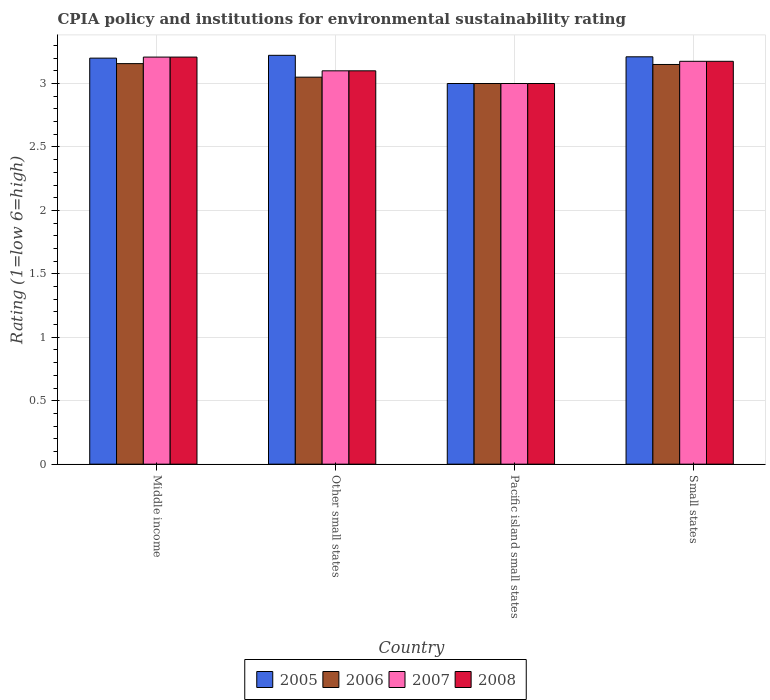How many different coloured bars are there?
Offer a very short reply. 4. How many groups of bars are there?
Your answer should be compact. 4. Are the number of bars per tick equal to the number of legend labels?
Your answer should be compact. Yes. Are the number of bars on each tick of the X-axis equal?
Your answer should be very brief. Yes. How many bars are there on the 4th tick from the left?
Provide a short and direct response. 4. What is the label of the 2nd group of bars from the left?
Provide a short and direct response. Other small states. What is the CPIA rating in 2005 in Other small states?
Ensure brevity in your answer.  3.22. Across all countries, what is the maximum CPIA rating in 2008?
Offer a very short reply. 3.21. Across all countries, what is the minimum CPIA rating in 2006?
Offer a terse response. 3. In which country was the CPIA rating in 2008 maximum?
Make the answer very short. Middle income. In which country was the CPIA rating in 2006 minimum?
Provide a short and direct response. Pacific island small states. What is the total CPIA rating in 2008 in the graph?
Make the answer very short. 12.48. What is the difference between the CPIA rating in 2006 in Middle income and that in Pacific island small states?
Offer a very short reply. 0.16. What is the difference between the CPIA rating in 2006 in Pacific island small states and the CPIA rating in 2005 in Other small states?
Your response must be concise. -0.22. What is the average CPIA rating in 2006 per country?
Offer a very short reply. 3.09. What is the difference between the CPIA rating of/in 2008 and CPIA rating of/in 2006 in Small states?
Keep it short and to the point. 0.02. What is the ratio of the CPIA rating in 2007 in Middle income to that in Other small states?
Ensure brevity in your answer.  1.03. Is the CPIA rating in 2007 in Pacific island small states less than that in Small states?
Ensure brevity in your answer.  Yes. Is the difference between the CPIA rating in 2008 in Middle income and Small states greater than the difference between the CPIA rating in 2006 in Middle income and Small states?
Offer a very short reply. Yes. What is the difference between the highest and the second highest CPIA rating in 2006?
Make the answer very short. -0.01. What is the difference between the highest and the lowest CPIA rating in 2008?
Your answer should be very brief. 0.21. In how many countries, is the CPIA rating in 2008 greater than the average CPIA rating in 2008 taken over all countries?
Give a very brief answer. 2. Is the sum of the CPIA rating in 2006 in Middle income and Pacific island small states greater than the maximum CPIA rating in 2008 across all countries?
Make the answer very short. Yes. Is it the case that in every country, the sum of the CPIA rating in 2006 and CPIA rating in 2008 is greater than the sum of CPIA rating in 2007 and CPIA rating in 2005?
Provide a succinct answer. No. What does the 4th bar from the left in Middle income represents?
Your answer should be compact. 2008. Are all the bars in the graph horizontal?
Keep it short and to the point. No. Does the graph contain any zero values?
Your response must be concise. No. Does the graph contain grids?
Give a very brief answer. Yes. How many legend labels are there?
Keep it short and to the point. 4. How are the legend labels stacked?
Your answer should be very brief. Horizontal. What is the title of the graph?
Your answer should be very brief. CPIA policy and institutions for environmental sustainability rating. What is the label or title of the X-axis?
Provide a short and direct response. Country. What is the label or title of the Y-axis?
Offer a terse response. Rating (1=low 6=high). What is the Rating (1=low 6=high) of 2005 in Middle income?
Give a very brief answer. 3.2. What is the Rating (1=low 6=high) in 2006 in Middle income?
Provide a succinct answer. 3.16. What is the Rating (1=low 6=high) in 2007 in Middle income?
Your response must be concise. 3.21. What is the Rating (1=low 6=high) of 2008 in Middle income?
Your answer should be very brief. 3.21. What is the Rating (1=low 6=high) of 2005 in Other small states?
Ensure brevity in your answer.  3.22. What is the Rating (1=low 6=high) of 2006 in Other small states?
Your answer should be very brief. 3.05. What is the Rating (1=low 6=high) in 2005 in Pacific island small states?
Your response must be concise. 3. What is the Rating (1=low 6=high) of 2007 in Pacific island small states?
Your answer should be very brief. 3. What is the Rating (1=low 6=high) in 2008 in Pacific island small states?
Provide a short and direct response. 3. What is the Rating (1=low 6=high) of 2005 in Small states?
Offer a very short reply. 3.21. What is the Rating (1=low 6=high) in 2006 in Small states?
Ensure brevity in your answer.  3.15. What is the Rating (1=low 6=high) in 2007 in Small states?
Provide a short and direct response. 3.17. What is the Rating (1=low 6=high) of 2008 in Small states?
Provide a short and direct response. 3.17. Across all countries, what is the maximum Rating (1=low 6=high) in 2005?
Your answer should be very brief. 3.22. Across all countries, what is the maximum Rating (1=low 6=high) of 2006?
Provide a succinct answer. 3.16. Across all countries, what is the maximum Rating (1=low 6=high) of 2007?
Your response must be concise. 3.21. Across all countries, what is the maximum Rating (1=low 6=high) of 2008?
Your answer should be very brief. 3.21. Across all countries, what is the minimum Rating (1=low 6=high) of 2006?
Make the answer very short. 3. Across all countries, what is the minimum Rating (1=low 6=high) in 2008?
Give a very brief answer. 3. What is the total Rating (1=low 6=high) in 2005 in the graph?
Keep it short and to the point. 12.63. What is the total Rating (1=low 6=high) in 2006 in the graph?
Offer a terse response. 12.36. What is the total Rating (1=low 6=high) in 2007 in the graph?
Provide a succinct answer. 12.48. What is the total Rating (1=low 6=high) of 2008 in the graph?
Offer a very short reply. 12.48. What is the difference between the Rating (1=low 6=high) of 2005 in Middle income and that in Other small states?
Give a very brief answer. -0.02. What is the difference between the Rating (1=low 6=high) in 2006 in Middle income and that in Other small states?
Provide a short and direct response. 0.11. What is the difference between the Rating (1=low 6=high) of 2007 in Middle income and that in Other small states?
Offer a terse response. 0.11. What is the difference between the Rating (1=low 6=high) of 2008 in Middle income and that in Other small states?
Your response must be concise. 0.11. What is the difference between the Rating (1=low 6=high) of 2005 in Middle income and that in Pacific island small states?
Your answer should be compact. 0.2. What is the difference between the Rating (1=low 6=high) in 2006 in Middle income and that in Pacific island small states?
Ensure brevity in your answer.  0.16. What is the difference between the Rating (1=low 6=high) in 2007 in Middle income and that in Pacific island small states?
Keep it short and to the point. 0.21. What is the difference between the Rating (1=low 6=high) in 2008 in Middle income and that in Pacific island small states?
Provide a succinct answer. 0.21. What is the difference between the Rating (1=low 6=high) in 2005 in Middle income and that in Small states?
Offer a very short reply. -0.01. What is the difference between the Rating (1=low 6=high) in 2006 in Middle income and that in Small states?
Offer a terse response. 0.01. What is the difference between the Rating (1=low 6=high) of 2008 in Middle income and that in Small states?
Keep it short and to the point. 0.03. What is the difference between the Rating (1=low 6=high) in 2005 in Other small states and that in Pacific island small states?
Give a very brief answer. 0.22. What is the difference between the Rating (1=low 6=high) of 2006 in Other small states and that in Pacific island small states?
Keep it short and to the point. 0.05. What is the difference between the Rating (1=low 6=high) in 2005 in Other small states and that in Small states?
Offer a terse response. 0.01. What is the difference between the Rating (1=low 6=high) of 2006 in Other small states and that in Small states?
Give a very brief answer. -0.1. What is the difference between the Rating (1=low 6=high) in 2007 in Other small states and that in Small states?
Make the answer very short. -0.07. What is the difference between the Rating (1=low 6=high) of 2008 in Other small states and that in Small states?
Your answer should be compact. -0.07. What is the difference between the Rating (1=low 6=high) in 2005 in Pacific island small states and that in Small states?
Provide a succinct answer. -0.21. What is the difference between the Rating (1=low 6=high) of 2006 in Pacific island small states and that in Small states?
Keep it short and to the point. -0.15. What is the difference between the Rating (1=low 6=high) of 2007 in Pacific island small states and that in Small states?
Your answer should be compact. -0.17. What is the difference between the Rating (1=low 6=high) of 2008 in Pacific island small states and that in Small states?
Provide a short and direct response. -0.17. What is the difference between the Rating (1=low 6=high) of 2005 in Middle income and the Rating (1=low 6=high) of 2006 in Other small states?
Offer a terse response. 0.15. What is the difference between the Rating (1=low 6=high) in 2005 in Middle income and the Rating (1=low 6=high) in 2007 in Other small states?
Provide a short and direct response. 0.1. What is the difference between the Rating (1=low 6=high) in 2005 in Middle income and the Rating (1=low 6=high) in 2008 in Other small states?
Make the answer very short. 0.1. What is the difference between the Rating (1=low 6=high) of 2006 in Middle income and the Rating (1=low 6=high) of 2007 in Other small states?
Your answer should be compact. 0.06. What is the difference between the Rating (1=low 6=high) of 2006 in Middle income and the Rating (1=low 6=high) of 2008 in Other small states?
Make the answer very short. 0.06. What is the difference between the Rating (1=low 6=high) in 2007 in Middle income and the Rating (1=low 6=high) in 2008 in Other small states?
Keep it short and to the point. 0.11. What is the difference between the Rating (1=low 6=high) of 2005 in Middle income and the Rating (1=low 6=high) of 2008 in Pacific island small states?
Your answer should be compact. 0.2. What is the difference between the Rating (1=low 6=high) in 2006 in Middle income and the Rating (1=low 6=high) in 2007 in Pacific island small states?
Your answer should be very brief. 0.16. What is the difference between the Rating (1=low 6=high) in 2006 in Middle income and the Rating (1=low 6=high) in 2008 in Pacific island small states?
Your response must be concise. 0.16. What is the difference between the Rating (1=low 6=high) in 2007 in Middle income and the Rating (1=low 6=high) in 2008 in Pacific island small states?
Ensure brevity in your answer.  0.21. What is the difference between the Rating (1=low 6=high) in 2005 in Middle income and the Rating (1=low 6=high) in 2007 in Small states?
Provide a short and direct response. 0.03. What is the difference between the Rating (1=low 6=high) of 2005 in Middle income and the Rating (1=low 6=high) of 2008 in Small states?
Keep it short and to the point. 0.03. What is the difference between the Rating (1=low 6=high) in 2006 in Middle income and the Rating (1=low 6=high) in 2007 in Small states?
Your response must be concise. -0.02. What is the difference between the Rating (1=low 6=high) in 2006 in Middle income and the Rating (1=low 6=high) in 2008 in Small states?
Your answer should be compact. -0.02. What is the difference between the Rating (1=low 6=high) of 2005 in Other small states and the Rating (1=low 6=high) of 2006 in Pacific island small states?
Provide a succinct answer. 0.22. What is the difference between the Rating (1=low 6=high) of 2005 in Other small states and the Rating (1=low 6=high) of 2007 in Pacific island small states?
Give a very brief answer. 0.22. What is the difference between the Rating (1=low 6=high) in 2005 in Other small states and the Rating (1=low 6=high) in 2008 in Pacific island small states?
Make the answer very short. 0.22. What is the difference between the Rating (1=low 6=high) in 2006 in Other small states and the Rating (1=low 6=high) in 2007 in Pacific island small states?
Keep it short and to the point. 0.05. What is the difference between the Rating (1=low 6=high) in 2006 in Other small states and the Rating (1=low 6=high) in 2008 in Pacific island small states?
Your answer should be very brief. 0.05. What is the difference between the Rating (1=low 6=high) of 2005 in Other small states and the Rating (1=low 6=high) of 2006 in Small states?
Provide a short and direct response. 0.07. What is the difference between the Rating (1=low 6=high) in 2005 in Other small states and the Rating (1=low 6=high) in 2007 in Small states?
Make the answer very short. 0.05. What is the difference between the Rating (1=low 6=high) in 2005 in Other small states and the Rating (1=low 6=high) in 2008 in Small states?
Keep it short and to the point. 0.05. What is the difference between the Rating (1=low 6=high) in 2006 in Other small states and the Rating (1=low 6=high) in 2007 in Small states?
Your answer should be compact. -0.12. What is the difference between the Rating (1=low 6=high) in 2006 in Other small states and the Rating (1=low 6=high) in 2008 in Small states?
Make the answer very short. -0.12. What is the difference between the Rating (1=low 6=high) in 2007 in Other small states and the Rating (1=low 6=high) in 2008 in Small states?
Ensure brevity in your answer.  -0.07. What is the difference between the Rating (1=low 6=high) of 2005 in Pacific island small states and the Rating (1=low 6=high) of 2006 in Small states?
Your answer should be very brief. -0.15. What is the difference between the Rating (1=low 6=high) of 2005 in Pacific island small states and the Rating (1=low 6=high) of 2007 in Small states?
Make the answer very short. -0.17. What is the difference between the Rating (1=low 6=high) of 2005 in Pacific island small states and the Rating (1=low 6=high) of 2008 in Small states?
Ensure brevity in your answer.  -0.17. What is the difference between the Rating (1=low 6=high) of 2006 in Pacific island small states and the Rating (1=low 6=high) of 2007 in Small states?
Give a very brief answer. -0.17. What is the difference between the Rating (1=low 6=high) of 2006 in Pacific island small states and the Rating (1=low 6=high) of 2008 in Small states?
Keep it short and to the point. -0.17. What is the difference between the Rating (1=low 6=high) of 2007 in Pacific island small states and the Rating (1=low 6=high) of 2008 in Small states?
Provide a short and direct response. -0.17. What is the average Rating (1=low 6=high) in 2005 per country?
Make the answer very short. 3.16. What is the average Rating (1=low 6=high) in 2006 per country?
Make the answer very short. 3.09. What is the average Rating (1=low 6=high) of 2007 per country?
Offer a very short reply. 3.12. What is the average Rating (1=low 6=high) of 2008 per country?
Offer a very short reply. 3.12. What is the difference between the Rating (1=low 6=high) of 2005 and Rating (1=low 6=high) of 2006 in Middle income?
Make the answer very short. 0.04. What is the difference between the Rating (1=low 6=high) of 2005 and Rating (1=low 6=high) of 2007 in Middle income?
Provide a short and direct response. -0.01. What is the difference between the Rating (1=low 6=high) of 2005 and Rating (1=low 6=high) of 2008 in Middle income?
Offer a terse response. -0.01. What is the difference between the Rating (1=low 6=high) of 2006 and Rating (1=low 6=high) of 2007 in Middle income?
Your response must be concise. -0.05. What is the difference between the Rating (1=low 6=high) of 2006 and Rating (1=low 6=high) of 2008 in Middle income?
Your answer should be compact. -0.05. What is the difference between the Rating (1=low 6=high) of 2007 and Rating (1=low 6=high) of 2008 in Middle income?
Offer a terse response. 0. What is the difference between the Rating (1=low 6=high) in 2005 and Rating (1=low 6=high) in 2006 in Other small states?
Your answer should be compact. 0.17. What is the difference between the Rating (1=low 6=high) of 2005 and Rating (1=low 6=high) of 2007 in Other small states?
Offer a terse response. 0.12. What is the difference between the Rating (1=low 6=high) of 2005 and Rating (1=low 6=high) of 2008 in Other small states?
Offer a terse response. 0.12. What is the difference between the Rating (1=low 6=high) of 2006 and Rating (1=low 6=high) of 2007 in Other small states?
Provide a succinct answer. -0.05. What is the difference between the Rating (1=low 6=high) in 2005 and Rating (1=low 6=high) in 2006 in Pacific island small states?
Make the answer very short. 0. What is the difference between the Rating (1=low 6=high) in 2005 and Rating (1=low 6=high) in 2007 in Pacific island small states?
Your answer should be very brief. 0. What is the difference between the Rating (1=low 6=high) of 2005 and Rating (1=low 6=high) of 2008 in Pacific island small states?
Your answer should be very brief. 0. What is the difference between the Rating (1=low 6=high) of 2006 and Rating (1=low 6=high) of 2007 in Pacific island small states?
Make the answer very short. 0. What is the difference between the Rating (1=low 6=high) in 2005 and Rating (1=low 6=high) in 2006 in Small states?
Offer a terse response. 0.06. What is the difference between the Rating (1=low 6=high) in 2005 and Rating (1=low 6=high) in 2007 in Small states?
Offer a very short reply. 0.04. What is the difference between the Rating (1=low 6=high) of 2005 and Rating (1=low 6=high) of 2008 in Small states?
Offer a very short reply. 0.04. What is the difference between the Rating (1=low 6=high) in 2006 and Rating (1=low 6=high) in 2007 in Small states?
Give a very brief answer. -0.03. What is the difference between the Rating (1=low 6=high) of 2006 and Rating (1=low 6=high) of 2008 in Small states?
Your answer should be very brief. -0.03. What is the ratio of the Rating (1=low 6=high) of 2006 in Middle income to that in Other small states?
Your answer should be very brief. 1.03. What is the ratio of the Rating (1=low 6=high) in 2007 in Middle income to that in Other small states?
Ensure brevity in your answer.  1.03. What is the ratio of the Rating (1=low 6=high) in 2008 in Middle income to that in Other small states?
Offer a very short reply. 1.03. What is the ratio of the Rating (1=low 6=high) of 2005 in Middle income to that in Pacific island small states?
Offer a terse response. 1.07. What is the ratio of the Rating (1=low 6=high) in 2006 in Middle income to that in Pacific island small states?
Your response must be concise. 1.05. What is the ratio of the Rating (1=low 6=high) in 2007 in Middle income to that in Pacific island small states?
Your answer should be compact. 1.07. What is the ratio of the Rating (1=low 6=high) of 2008 in Middle income to that in Pacific island small states?
Keep it short and to the point. 1.07. What is the ratio of the Rating (1=low 6=high) of 2006 in Middle income to that in Small states?
Ensure brevity in your answer.  1. What is the ratio of the Rating (1=low 6=high) of 2007 in Middle income to that in Small states?
Your answer should be very brief. 1.01. What is the ratio of the Rating (1=low 6=high) of 2008 in Middle income to that in Small states?
Your answer should be compact. 1.01. What is the ratio of the Rating (1=low 6=high) of 2005 in Other small states to that in Pacific island small states?
Offer a terse response. 1.07. What is the ratio of the Rating (1=low 6=high) in 2006 in Other small states to that in Pacific island small states?
Make the answer very short. 1.02. What is the ratio of the Rating (1=low 6=high) of 2006 in Other small states to that in Small states?
Your answer should be very brief. 0.97. What is the ratio of the Rating (1=low 6=high) of 2007 in Other small states to that in Small states?
Provide a short and direct response. 0.98. What is the ratio of the Rating (1=low 6=high) in 2008 in Other small states to that in Small states?
Offer a very short reply. 0.98. What is the ratio of the Rating (1=low 6=high) in 2005 in Pacific island small states to that in Small states?
Your response must be concise. 0.93. What is the ratio of the Rating (1=low 6=high) in 2007 in Pacific island small states to that in Small states?
Give a very brief answer. 0.94. What is the ratio of the Rating (1=low 6=high) of 2008 in Pacific island small states to that in Small states?
Offer a very short reply. 0.94. What is the difference between the highest and the second highest Rating (1=low 6=high) of 2005?
Provide a short and direct response. 0.01. What is the difference between the highest and the second highest Rating (1=low 6=high) of 2006?
Ensure brevity in your answer.  0.01. What is the difference between the highest and the second highest Rating (1=low 6=high) in 2007?
Offer a terse response. 0.03. What is the difference between the highest and the second highest Rating (1=low 6=high) in 2008?
Ensure brevity in your answer.  0.03. What is the difference between the highest and the lowest Rating (1=low 6=high) of 2005?
Your answer should be very brief. 0.22. What is the difference between the highest and the lowest Rating (1=low 6=high) of 2006?
Provide a succinct answer. 0.16. What is the difference between the highest and the lowest Rating (1=low 6=high) of 2007?
Offer a terse response. 0.21. What is the difference between the highest and the lowest Rating (1=low 6=high) of 2008?
Make the answer very short. 0.21. 